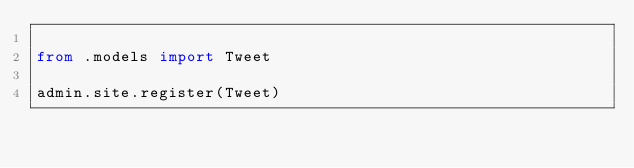Convert code to text. <code><loc_0><loc_0><loc_500><loc_500><_Python_>
from .models import Tweet

admin.site.register(Tweet)
</code> 